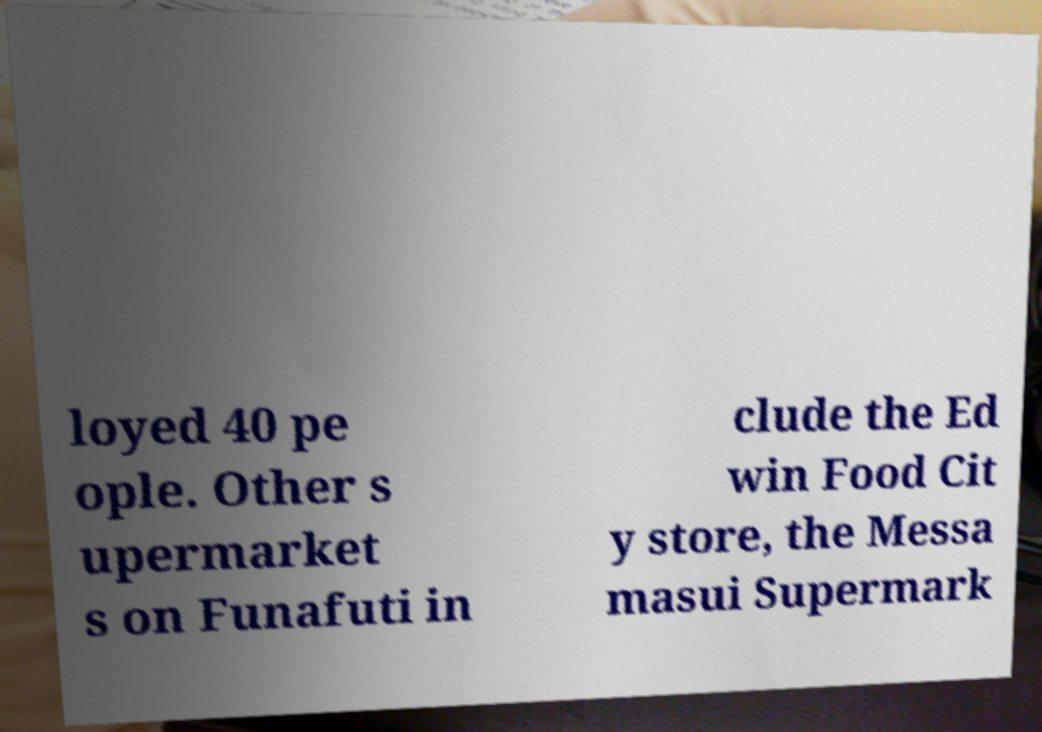Please read and relay the text visible in this image. What does it say? loyed 40 pe ople. Other s upermarket s on Funafuti in clude the Ed win Food Cit y store, the Messa masui Supermark 